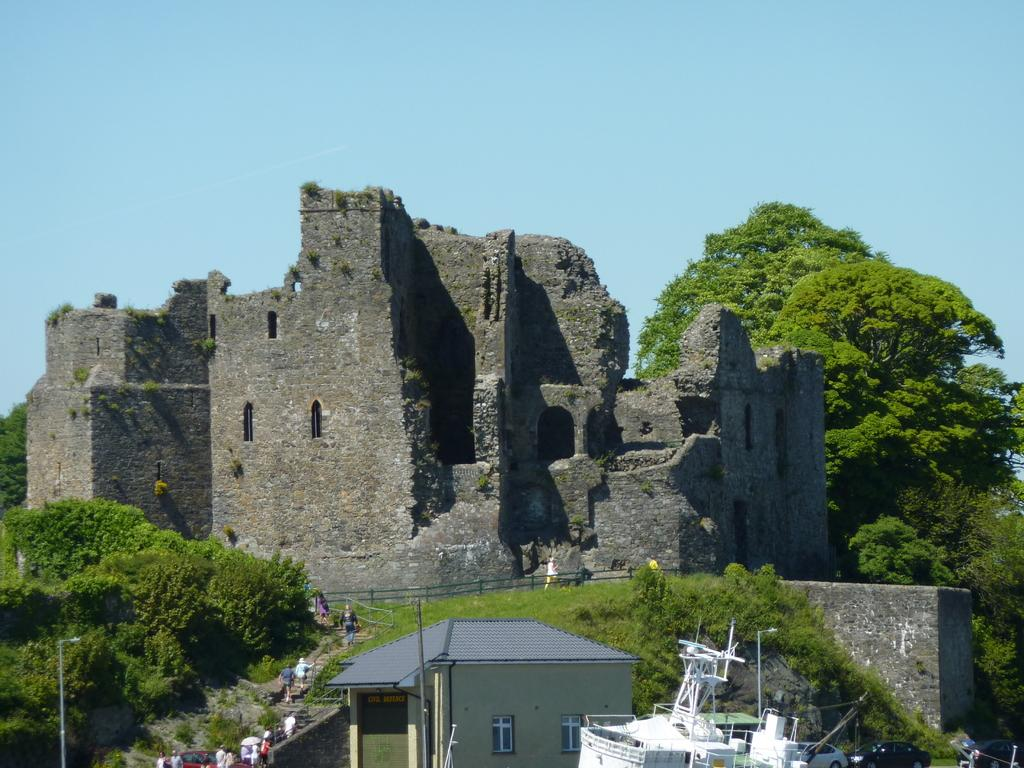What type of structure is shown in the image? The image depicts an ancient fort. Are there any people visiting the fort? Yes, tourists are visiting the fort. What can be seen in the vicinity of the fort? There are trees surrounding the fort, and there is a small house in front of the fort. What is located beside the house? Vehicles are present beside the house. How many bushes are growing on the side of the fort? There is no mention of bushes in the image, so it is impossible to determine their number or presence. 